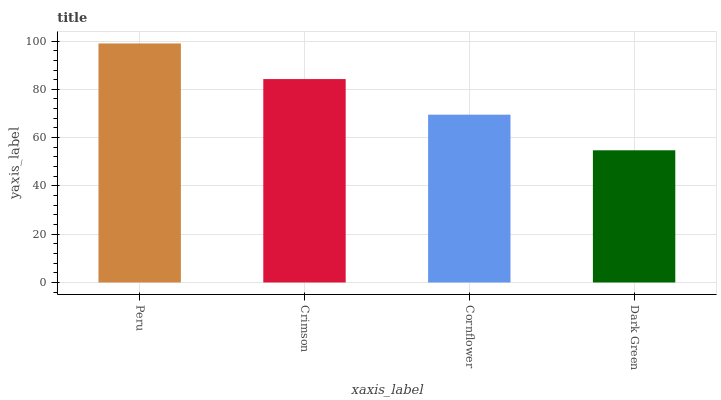Is Crimson the minimum?
Answer yes or no. No. Is Crimson the maximum?
Answer yes or no. No. Is Peru greater than Crimson?
Answer yes or no. Yes. Is Crimson less than Peru?
Answer yes or no. Yes. Is Crimson greater than Peru?
Answer yes or no. No. Is Peru less than Crimson?
Answer yes or no. No. Is Crimson the high median?
Answer yes or no. Yes. Is Cornflower the low median?
Answer yes or no. Yes. Is Cornflower the high median?
Answer yes or no. No. Is Peru the low median?
Answer yes or no. No. 